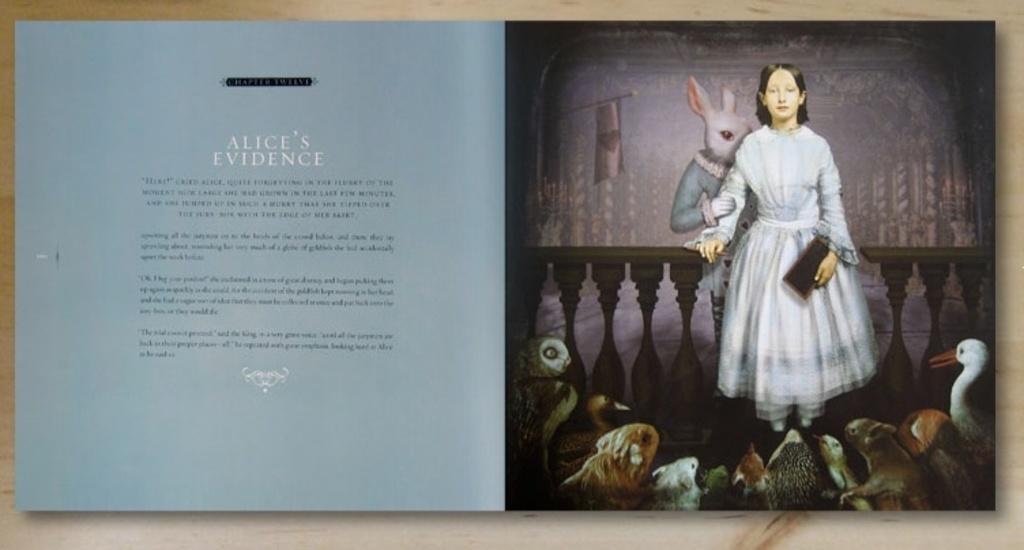In one or two sentences, can you explain what this image depicts? In this image I can see a person standing and holding book. I can see an animal standing and holding fencing. I can see a flag,pillars and few animals in front. 